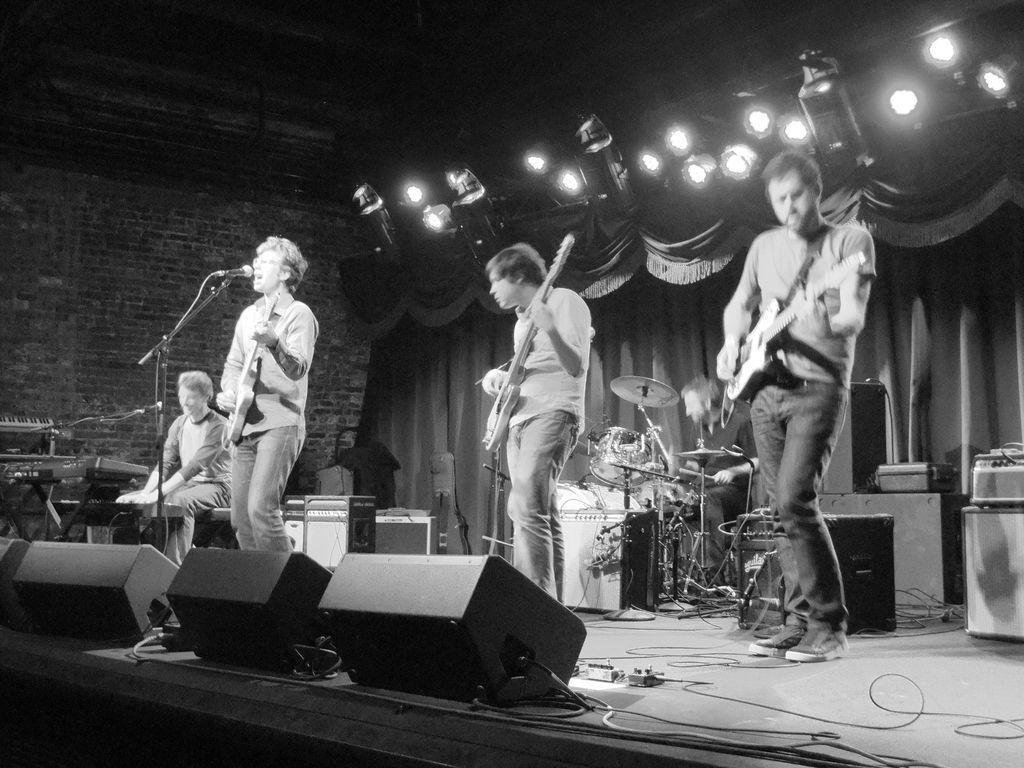How would you summarize this image in a sentence or two? In this image I can see four people were three of them standing and holding guitars. In the background I can see one more person sitting next to a drum set. I can also see few mics, speakers and number of lights in the background. 